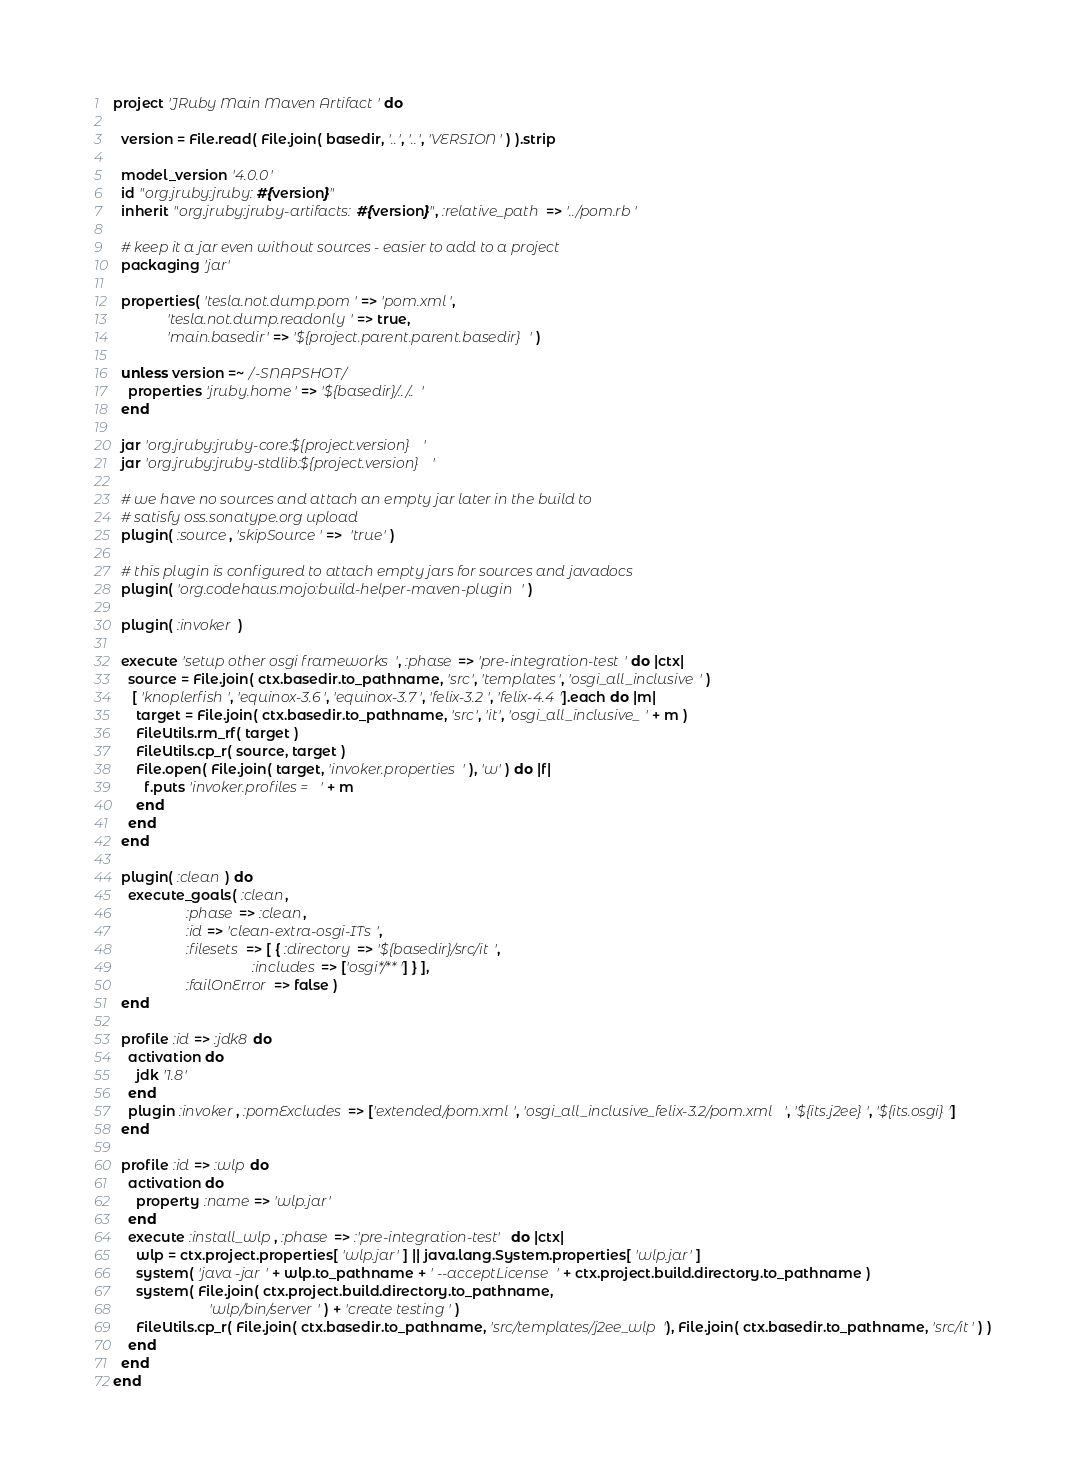Convert code to text. <code><loc_0><loc_0><loc_500><loc_500><_Ruby_>project 'JRuby Main Maven Artifact' do

  version = File.read( File.join( basedir, '..', '..', 'VERSION' ) ).strip

  model_version '4.0.0'
  id "org.jruby:jruby:#{version}"
  inherit "org.jruby:jruby-artifacts:#{version}", :relative_path => '../pom.rb'

  # keep it a jar even without sources - easier to add to a project
  packaging 'jar'

  properties( 'tesla.not.dump.pom' => 'pom.xml',
              'tesla.not.dump.readonly' => true,
              'main.basedir' => '${project.parent.parent.basedir}' )

  unless version =~ /-SNAPSHOT/
    properties 'jruby.home' => '${basedir}/../..'
  end

  jar 'org.jruby:jruby-core:${project.version}'
  jar 'org.jruby:jruby-stdlib:${project.version}'

  # we have no sources and attach an empty jar later in the build to
  # satisfy oss.sonatype.org upload
  plugin( :source, 'skipSource' =>  'true' )

  # this plugin is configured to attach empty jars for sources and javadocs
  plugin( 'org.codehaus.mojo:build-helper-maven-plugin' )

  plugin( :invoker )

  execute 'setup other osgi frameworks', :phase => 'pre-integration-test' do |ctx|
    source = File.join( ctx.basedir.to_pathname, 'src', 'templates', 'osgi_all_inclusive' )
     [ 'knoplerfish', 'equinox-3.6', 'equinox-3.7', 'felix-3.2', 'felix-4.4'].each do |m|
      target = File.join( ctx.basedir.to_pathname, 'src', 'it', 'osgi_all_inclusive_' + m )
      FileUtils.rm_rf( target )
      FileUtils.cp_r( source, target )
      File.open( File.join( target, 'invoker.properties' ), 'w' ) do |f|
        f.puts 'invoker.profiles = ' + m
      end
    end
  end

  plugin( :clean ) do
    execute_goals( :clean,
                   :phase => :clean,
                   :id => 'clean-extra-osgi-ITs',
                   :filesets => [ { :directory => '${basedir}/src/it',
                                    :includes => ['osgi*/**'] } ],
                   :failOnError => false )
  end

  profile :id => :jdk8 do
    activation do
      jdk '1.8'
    end
    plugin :invoker, :pomExcludes => ['extended/pom.xml', 'osgi_all_inclusive_felix-3.2/pom.xml', '${its.j2ee}', '${its.osgi}']
  end

  profile :id => :wlp do
    activation do
      property :name => 'wlp.jar'
    end
    execute :install_wlp, :phase => :'pre-integration-test' do |ctx|
      wlp = ctx.project.properties[ 'wlp.jar' ] || java.lang.System.properties[ 'wlp.jar' ]
      system( 'java -jar ' + wlp.to_pathname + ' --acceptLicense ' + ctx.project.build.directory.to_pathname )
      system( File.join( ctx.project.build.directory.to_pathname,
                         'wlp/bin/server' ) + 'create testing' )
      FileUtils.cp_r( File.join( ctx.basedir.to_pathname, 'src/templates/j2ee_wlp'), File.join( ctx.basedir.to_pathname, 'src/it' ) )
    end
  end
end
</code> 